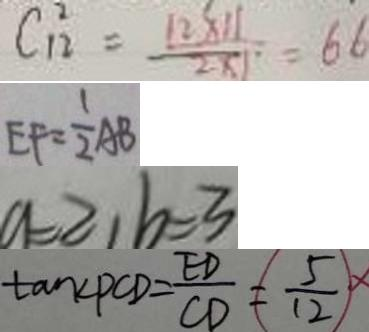<formula> <loc_0><loc_0><loc_500><loc_500>C _ { 1 2 } ^ { 2 } = \frac { 1 2 \times 1 1 } { 2 \times 1 } = 6 6 
 E F = \frac { 1 } { 2 } A B 
 a = 2 , b = 3 
 \tan \angle P C D = \frac { E D } { C D } = \frac { 5 } { 1 2 }</formula> 